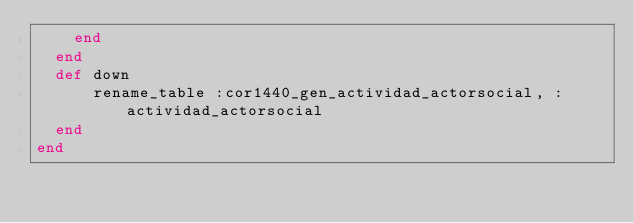<code> <loc_0><loc_0><loc_500><loc_500><_Ruby_>    end
  end
  def down
      rename_table :cor1440_gen_actividad_actorsocial, :actividad_actorsocial
  end
end
</code> 